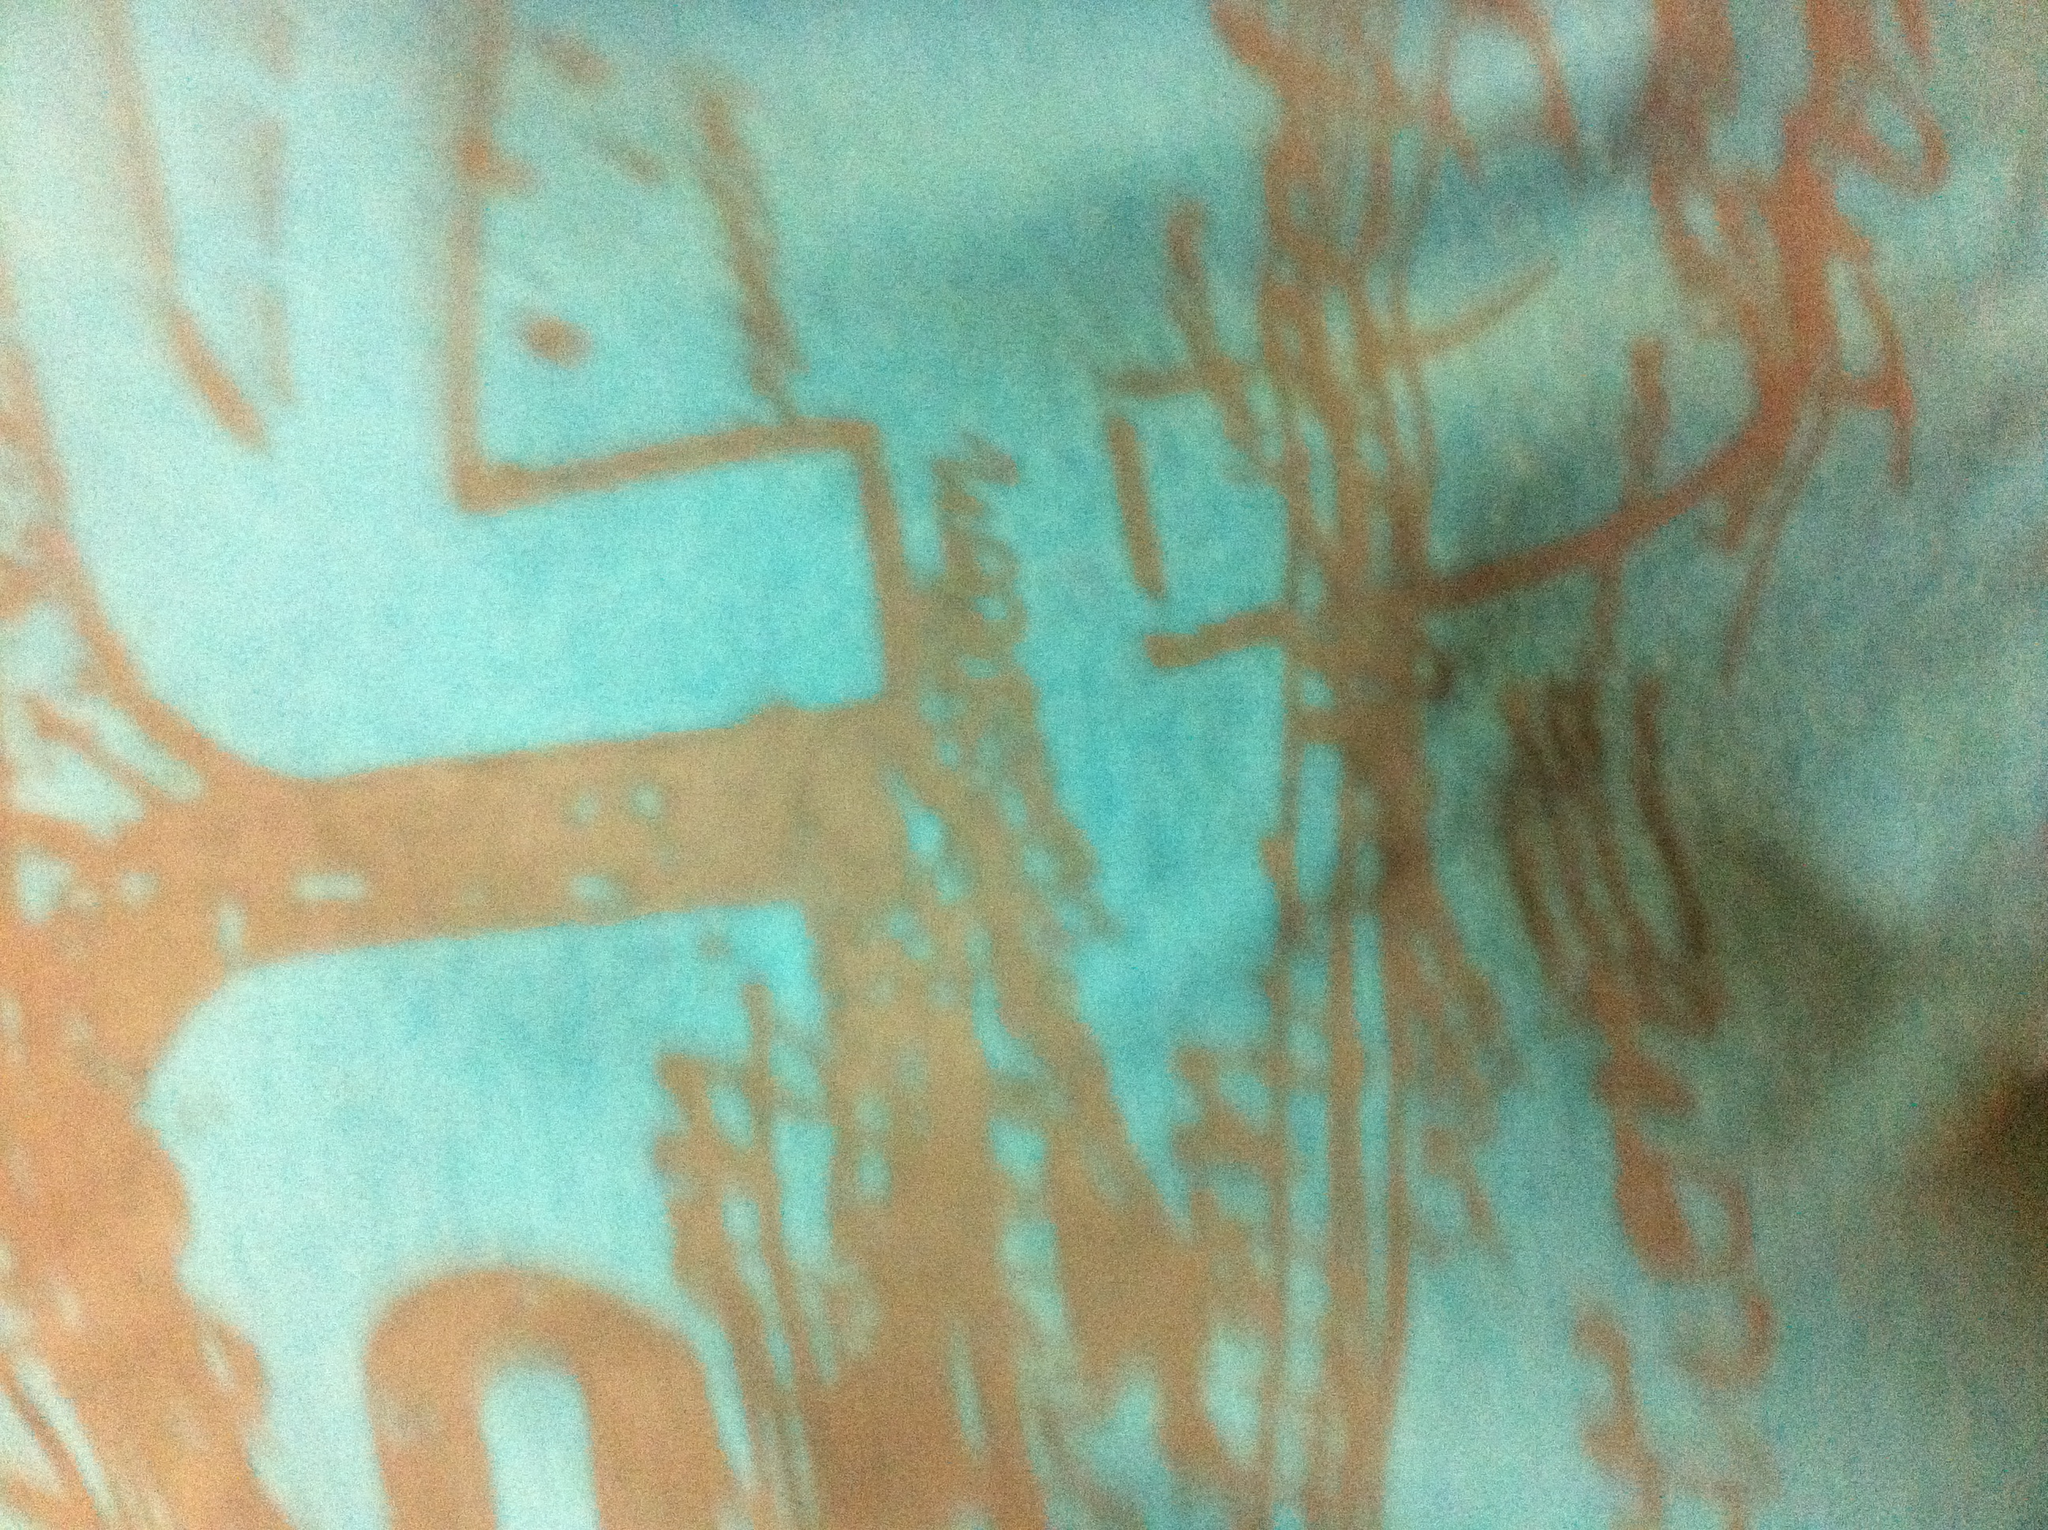What color is the shirt? The shirt in the image appears to be primarily turquoise or light blue with some orange or rusty patterns on it. 